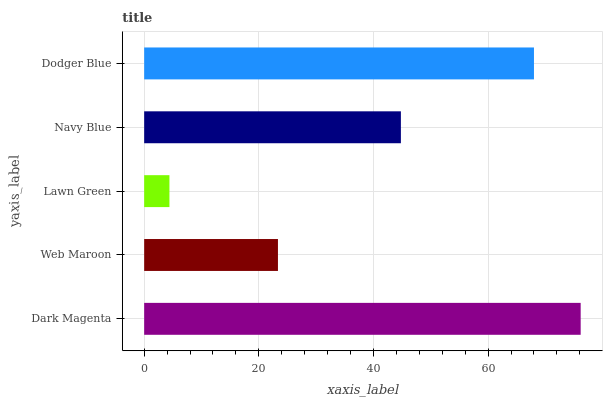Is Lawn Green the minimum?
Answer yes or no. Yes. Is Dark Magenta the maximum?
Answer yes or no. Yes. Is Web Maroon the minimum?
Answer yes or no. No. Is Web Maroon the maximum?
Answer yes or no. No. Is Dark Magenta greater than Web Maroon?
Answer yes or no. Yes. Is Web Maroon less than Dark Magenta?
Answer yes or no. Yes. Is Web Maroon greater than Dark Magenta?
Answer yes or no. No. Is Dark Magenta less than Web Maroon?
Answer yes or no. No. Is Navy Blue the high median?
Answer yes or no. Yes. Is Navy Blue the low median?
Answer yes or no. Yes. Is Dodger Blue the high median?
Answer yes or no. No. Is Dark Magenta the low median?
Answer yes or no. No. 